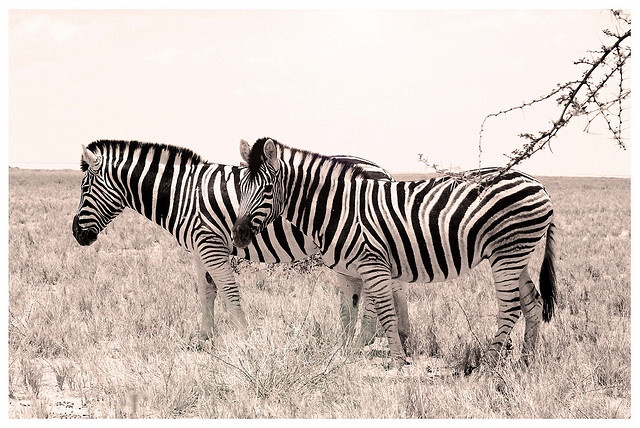Describe the objects in this image and their specific colors. I can see zebra in white, black, darkgray, and gray tones and zebra in white, black, and darkgray tones in this image. 